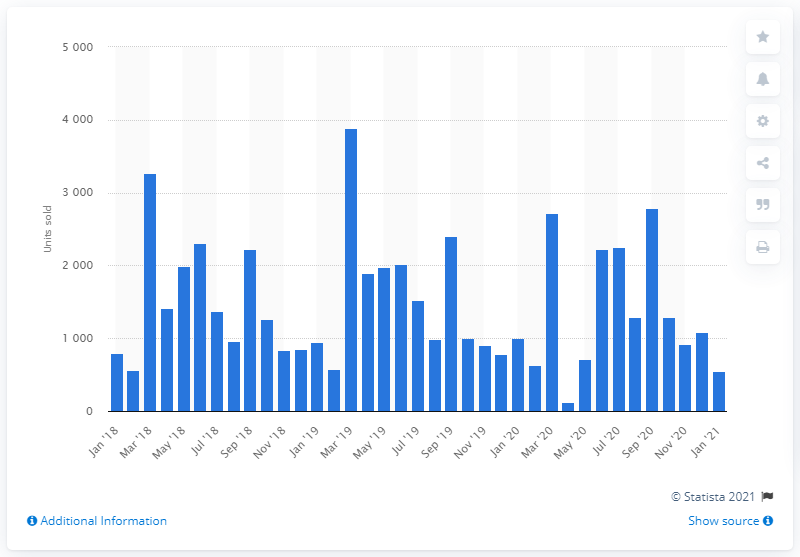List a handful of essential elements in this visual. In April 2020, the number of new motorcycle registrations was the lowest recorded at 126. 